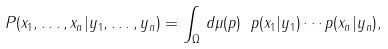<formula> <loc_0><loc_0><loc_500><loc_500>P ( x _ { 1 } , \dots , x _ { n } | y _ { 1 } , \dots , y _ { n } ) = \int _ { \Omega } \, d \mu ( p ) \ p ( x _ { 1 } | y _ { 1 } ) \cdots p ( x _ { n } | y _ { n } ) ,</formula> 